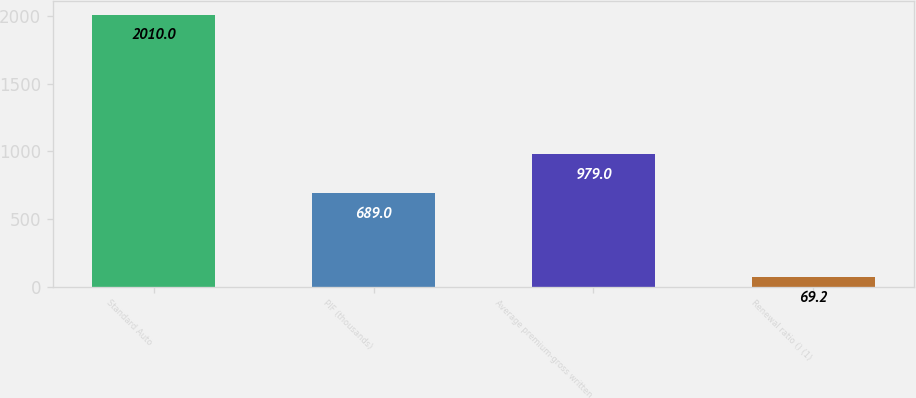Convert chart. <chart><loc_0><loc_0><loc_500><loc_500><bar_chart><fcel>Standard Auto<fcel>PIF (thousands)<fcel>Average premium-gross written<fcel>Renewal ratio () (1)<nl><fcel>2010<fcel>689<fcel>979<fcel>69.2<nl></chart> 